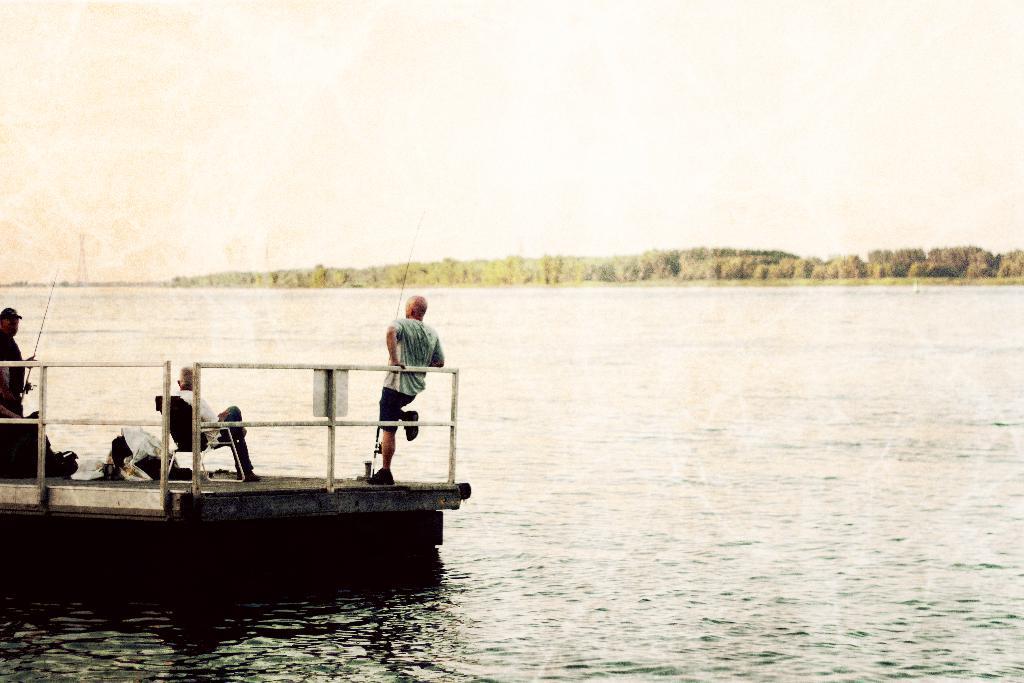In one or two sentences, can you explain what this image depicts? This picture is clicked outside. On the left we can see an object in the water body and we can see the two persons standing on the object and we can see a person sitting on the chair and there are some objects and the metal rods. In the background we can see the sky, trees and some other objects. 